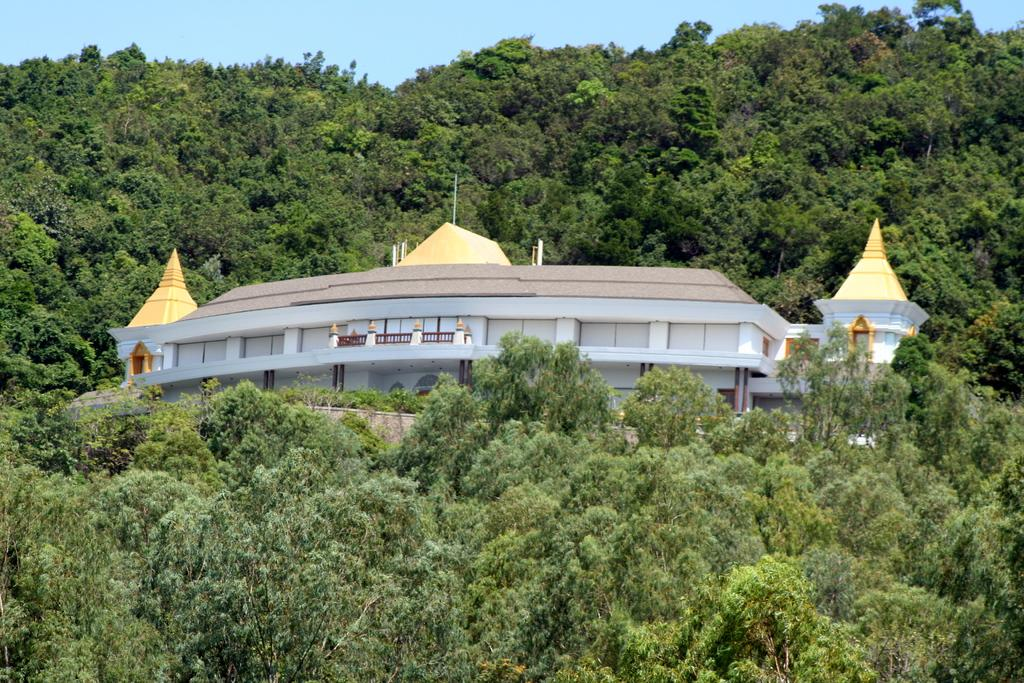What is the main subject of the image? There is a building at the center of the image. What can be seen around the building? There are trees around the building. What is visible in the background of the image? The sky is visible in the background of the image. What color is the dress worn by the partner in the image? There is no dress or partner present in the image; it features a building surrounded by trees with the sky visible in the background. 